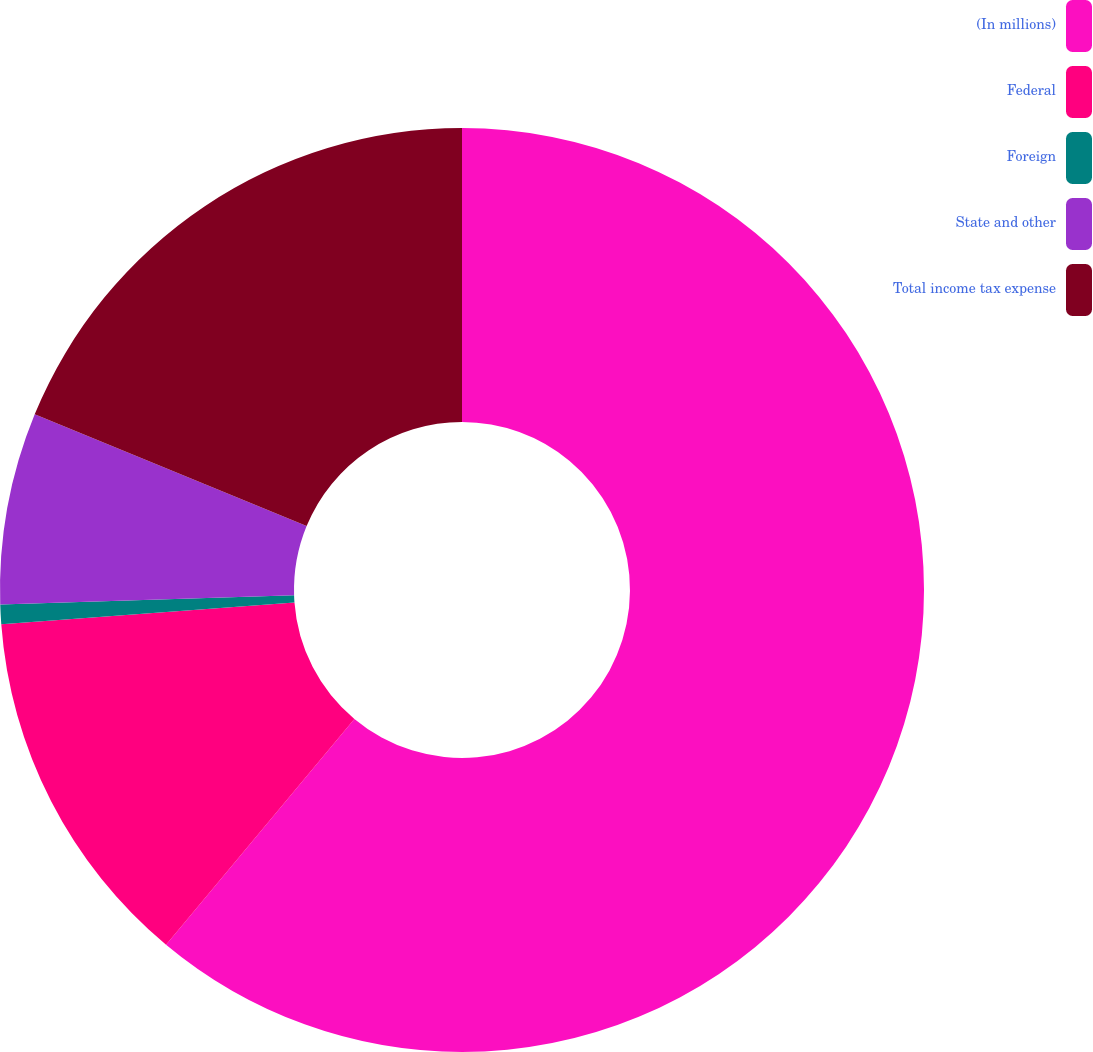<chart> <loc_0><loc_0><loc_500><loc_500><pie_chart><fcel>(In millions)<fcel>Federal<fcel>Foreign<fcel>State and other<fcel>Total income tax expense<nl><fcel>61.06%<fcel>12.75%<fcel>0.68%<fcel>6.71%<fcel>18.79%<nl></chart> 